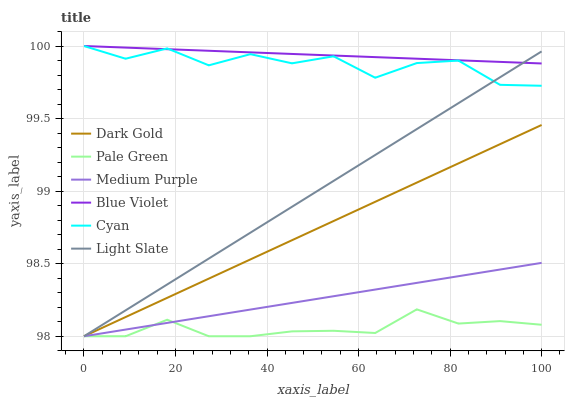Does Light Slate have the minimum area under the curve?
Answer yes or no. No. Does Light Slate have the maximum area under the curve?
Answer yes or no. No. Is Light Slate the smoothest?
Answer yes or no. No. Is Light Slate the roughest?
Answer yes or no. No. Does Cyan have the lowest value?
Answer yes or no. No. Does Light Slate have the highest value?
Answer yes or no. No. Is Dark Gold less than Blue Violet?
Answer yes or no. Yes. Is Blue Violet greater than Dark Gold?
Answer yes or no. Yes. Does Dark Gold intersect Blue Violet?
Answer yes or no. No. 